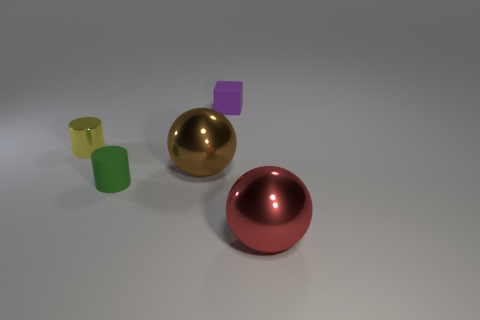Add 3 small green things. How many objects exist? 8 Subtract all red balls. How many balls are left? 1 Subtract all cylinders. How many objects are left? 3 Subtract 1 balls. How many balls are left? 1 Subtract all small cyan rubber cubes. Subtract all tiny rubber blocks. How many objects are left? 4 Add 4 big brown objects. How many big brown objects are left? 5 Add 5 large red things. How many large red things exist? 6 Subtract 0 yellow blocks. How many objects are left? 5 Subtract all yellow cylinders. Subtract all purple blocks. How many cylinders are left? 1 